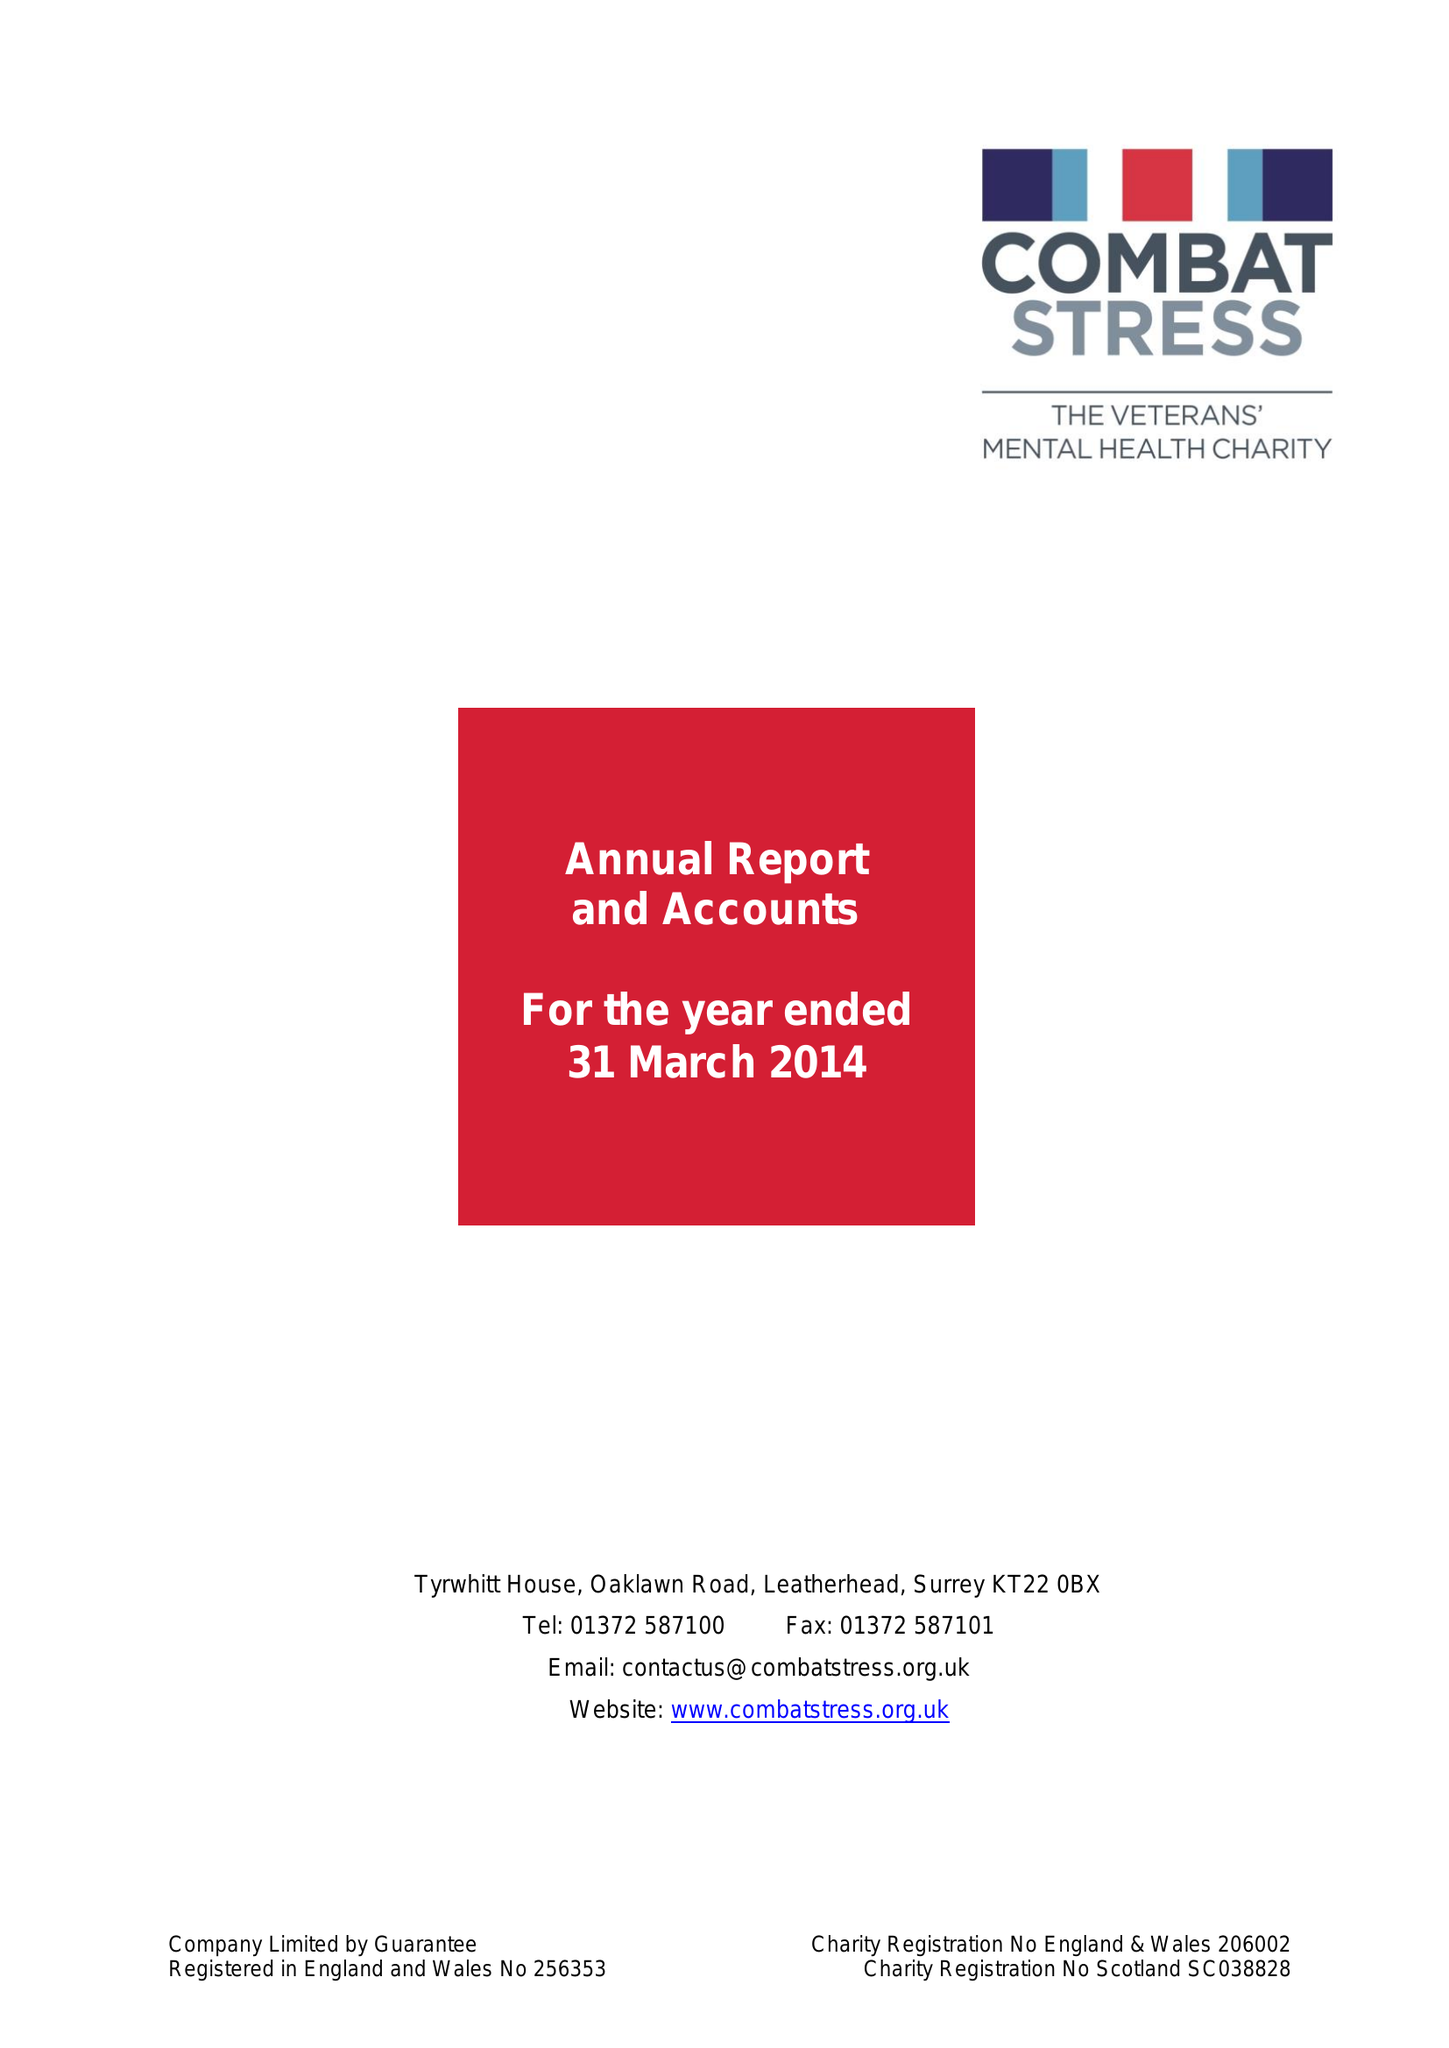What is the value for the address__street_line?
Answer the question using a single word or phrase. OAKLAWN ROAD 